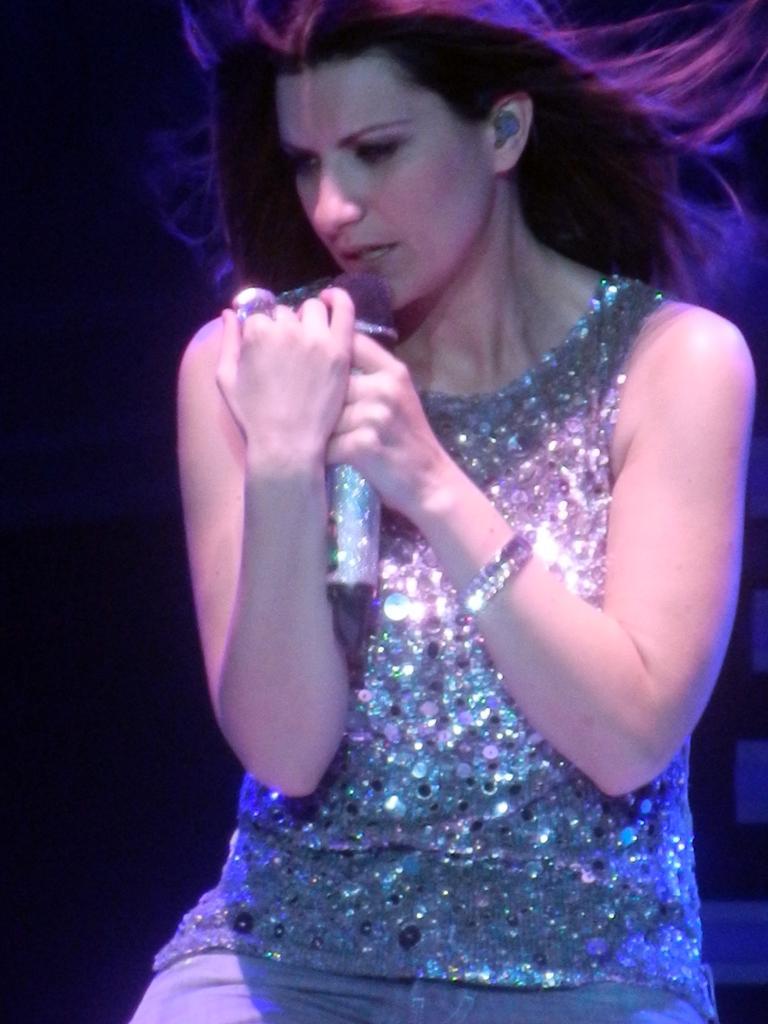Describe this image in one or two sentences. In this image we can see one woman sitting holding a microphone and singing. There are three objects behind the woman on the right side of the image and the background is dark. 